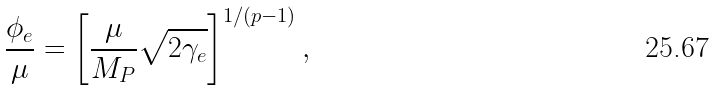<formula> <loc_0><loc_0><loc_500><loc_500>\frac { \phi _ { e } } { \mu } = \left [ \frac { \mu } { M _ { P } } \sqrt { 2 \gamma _ { e } } \right ] ^ { 1 / ( p - 1 ) } ,</formula> 